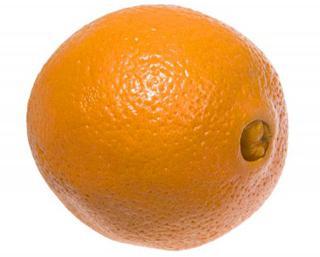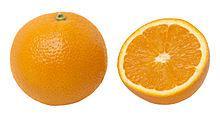The first image is the image on the left, the second image is the image on the right. Assess this claim about the two images: "There is at least one half of an orange along with other oranges.". Correct or not? Answer yes or no. Yes. 